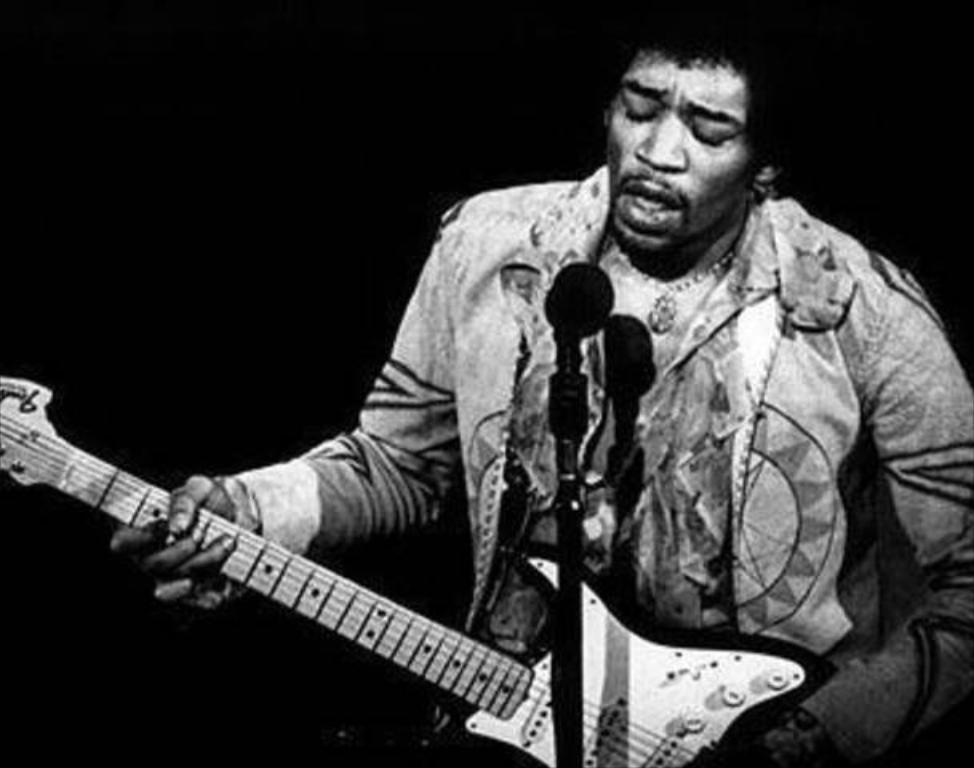Could you give a brief overview of what you see in this image? In this picture we can see man holding guitar in his hand and playing it and singing on mic and in background it is dark. 